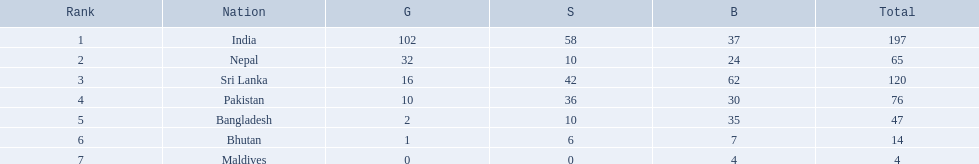What are the nations? India, Nepal, Sri Lanka, Pakistan, Bangladesh, Bhutan, Maldives. Of these, which one has earned the least amount of gold medals? Maldives. 